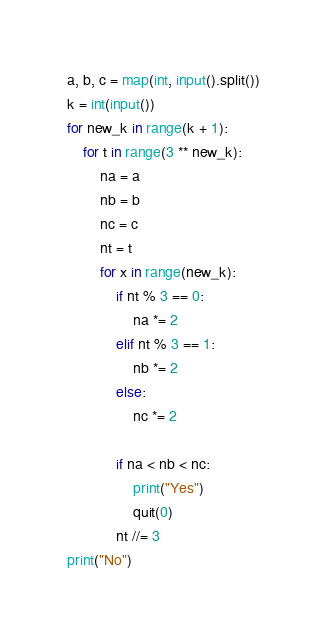Convert code to text. <code><loc_0><loc_0><loc_500><loc_500><_Python_>a, b, c = map(int, input().split())
k = int(input())
for new_k in range(k + 1):
    for t in range(3 ** new_k):
        na = a
        nb = b
        nc = c
        nt = t
        for x in range(new_k):
            if nt % 3 == 0:
                na *= 2
            elif nt % 3 == 1:
                nb *= 2
            else:
                nc *= 2

            if na < nb < nc:
                print("Yes")
                quit(0)
            nt //= 3
print("No")
</code> 